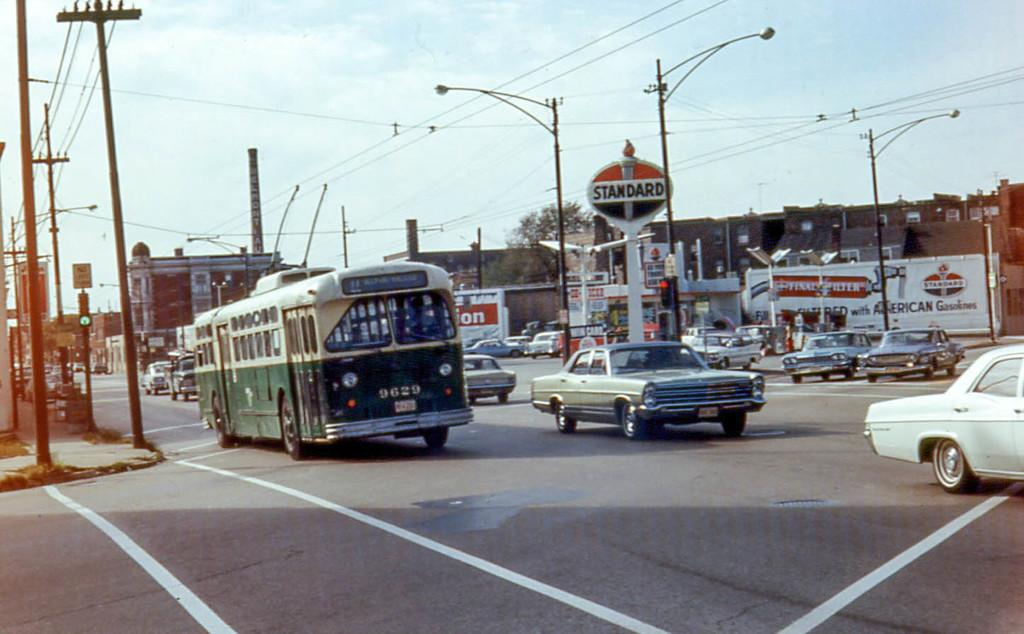<image>
Provide a brief description of the given image. A roadway with a green bus and lots of cars in front of a Standard gas station. 